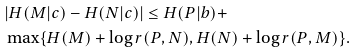Convert formula to latex. <formula><loc_0><loc_0><loc_500><loc_500>& | H ( M | c ) - H ( N | c ) | \leq H ( P | b ) + \\ & \max \{ H ( M ) + \log r ( P , N ) , H ( N ) + \log r ( P , M ) \} .</formula> 